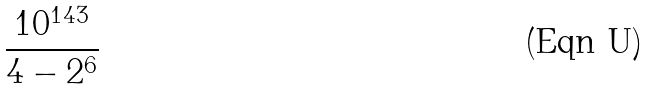<formula> <loc_0><loc_0><loc_500><loc_500>\frac { 1 0 ^ { 1 4 3 } } { 4 - 2 ^ { 6 } }</formula> 